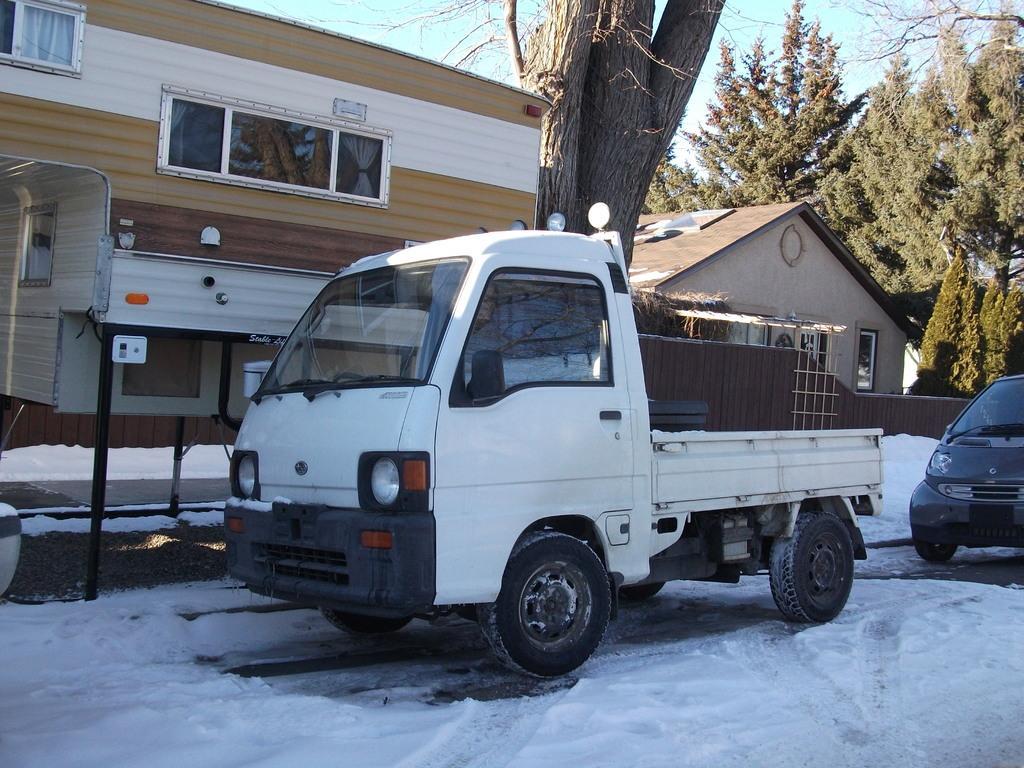Describe this image in one or two sentences. In the foreground of this image, there are two vehicles on the road. At the bottom, there is snow. In the background, there is a tree trunk, two buildings, few trees and the sky. 